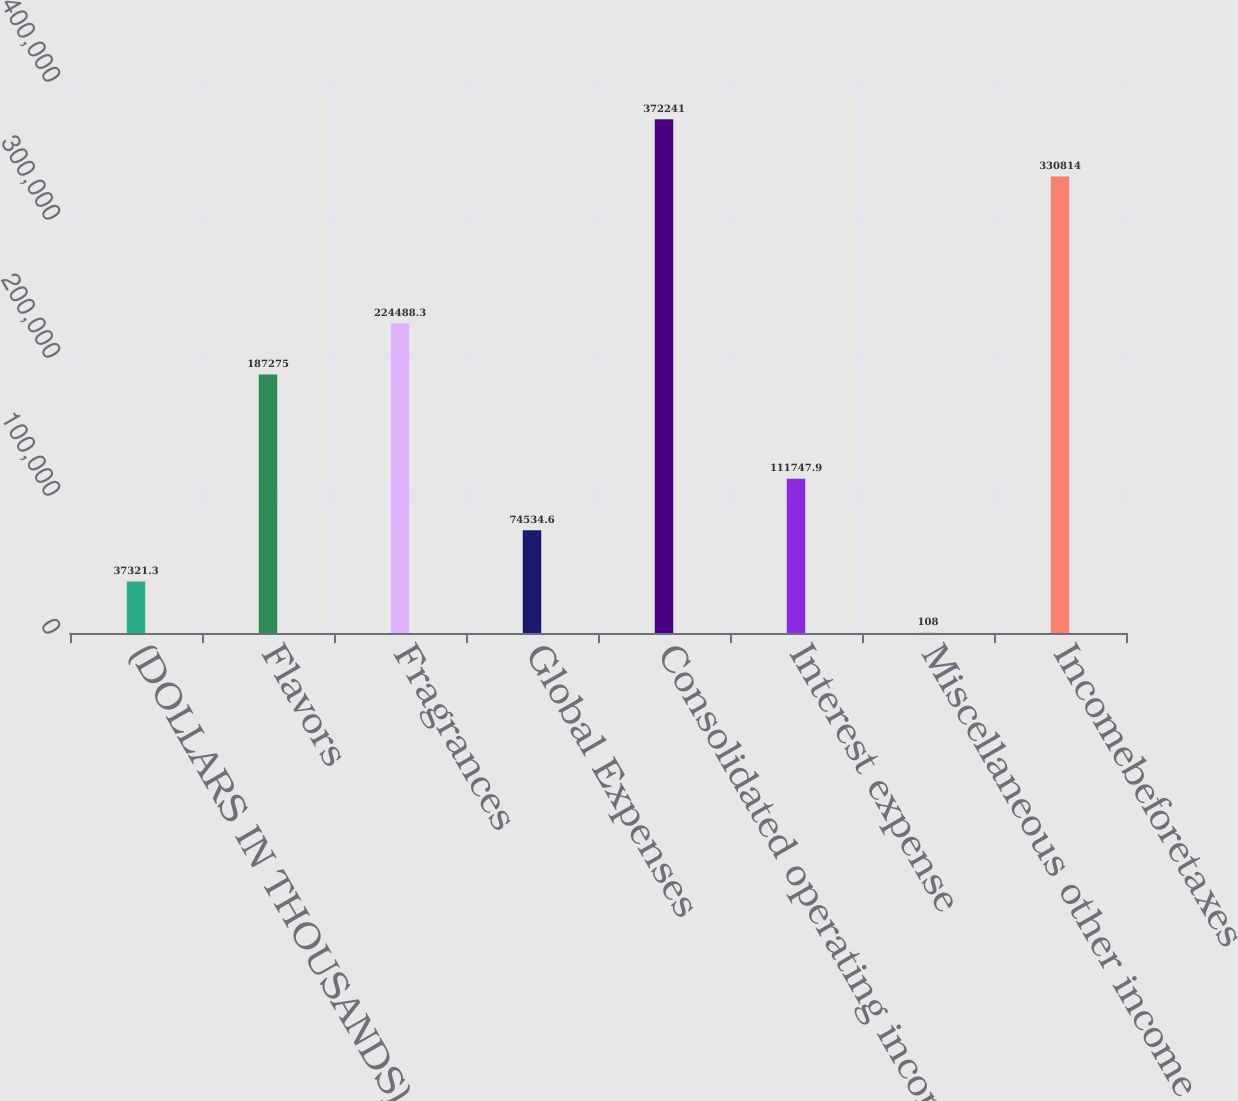Convert chart. <chart><loc_0><loc_0><loc_500><loc_500><bar_chart><fcel>(DOLLARS IN THOUSANDS)<fcel>Flavors<fcel>Fragrances<fcel>Global Expenses<fcel>Consolidated operating income<fcel>Interest expense<fcel>Miscellaneous other income<fcel>Incomebeforetaxes<nl><fcel>37321.3<fcel>187275<fcel>224488<fcel>74534.6<fcel>372241<fcel>111748<fcel>108<fcel>330814<nl></chart> 